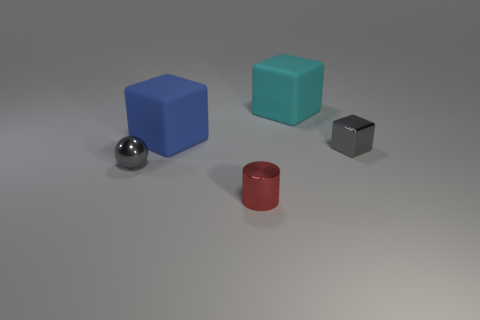Is the number of tiny red metallic objects left of the blue cube greater than the number of tiny gray metal spheres?
Offer a very short reply. No. Do the gray thing that is left of the large blue object and the small red object have the same material?
Offer a very short reply. Yes. There is a rubber block that is in front of the large cube right of the cube left of the cylinder; how big is it?
Your response must be concise. Large. What size is the blue thing that is the same material as the large cyan object?
Your response must be concise. Large. There is a shiny thing that is both left of the cyan rubber cube and on the right side of the large blue cube; what is its color?
Provide a short and direct response. Red. Is the shape of the cyan rubber object that is behind the small red shiny cylinder the same as the large blue matte object that is to the right of the metal sphere?
Provide a short and direct response. Yes. What material is the small ball that is to the left of the large cyan thing?
Your answer should be very brief. Metal. The metallic cube that is the same color as the ball is what size?
Your answer should be very brief. Small. What number of things are either tiny things behind the metallic sphere or purple matte objects?
Offer a very short reply. 1. Are there the same number of small red metal objects behind the gray cube and tiny green metal cylinders?
Offer a terse response. Yes. 